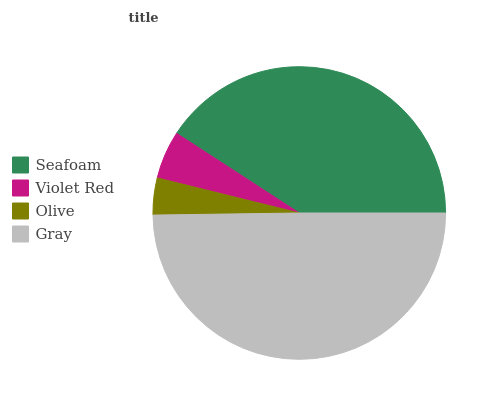Is Olive the minimum?
Answer yes or no. Yes. Is Gray the maximum?
Answer yes or no. Yes. Is Violet Red the minimum?
Answer yes or no. No. Is Violet Red the maximum?
Answer yes or no. No. Is Seafoam greater than Violet Red?
Answer yes or no. Yes. Is Violet Red less than Seafoam?
Answer yes or no. Yes. Is Violet Red greater than Seafoam?
Answer yes or no. No. Is Seafoam less than Violet Red?
Answer yes or no. No. Is Seafoam the high median?
Answer yes or no. Yes. Is Violet Red the low median?
Answer yes or no. Yes. Is Olive the high median?
Answer yes or no. No. Is Gray the low median?
Answer yes or no. No. 